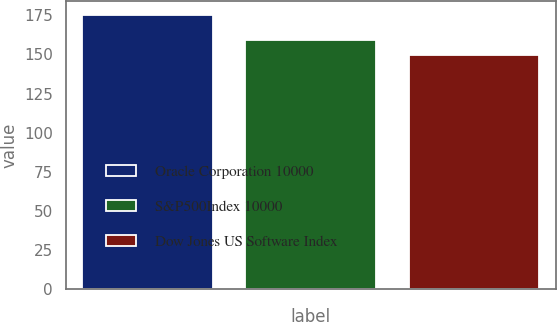Convert chart to OTSL. <chart><loc_0><loc_0><loc_500><loc_500><bar_chart><fcel>Oracle Corporation 10000<fcel>S&P500Index 10000<fcel>Dow Jones US Software Index<nl><fcel>175.56<fcel>159.4<fcel>149.95<nl></chart> 